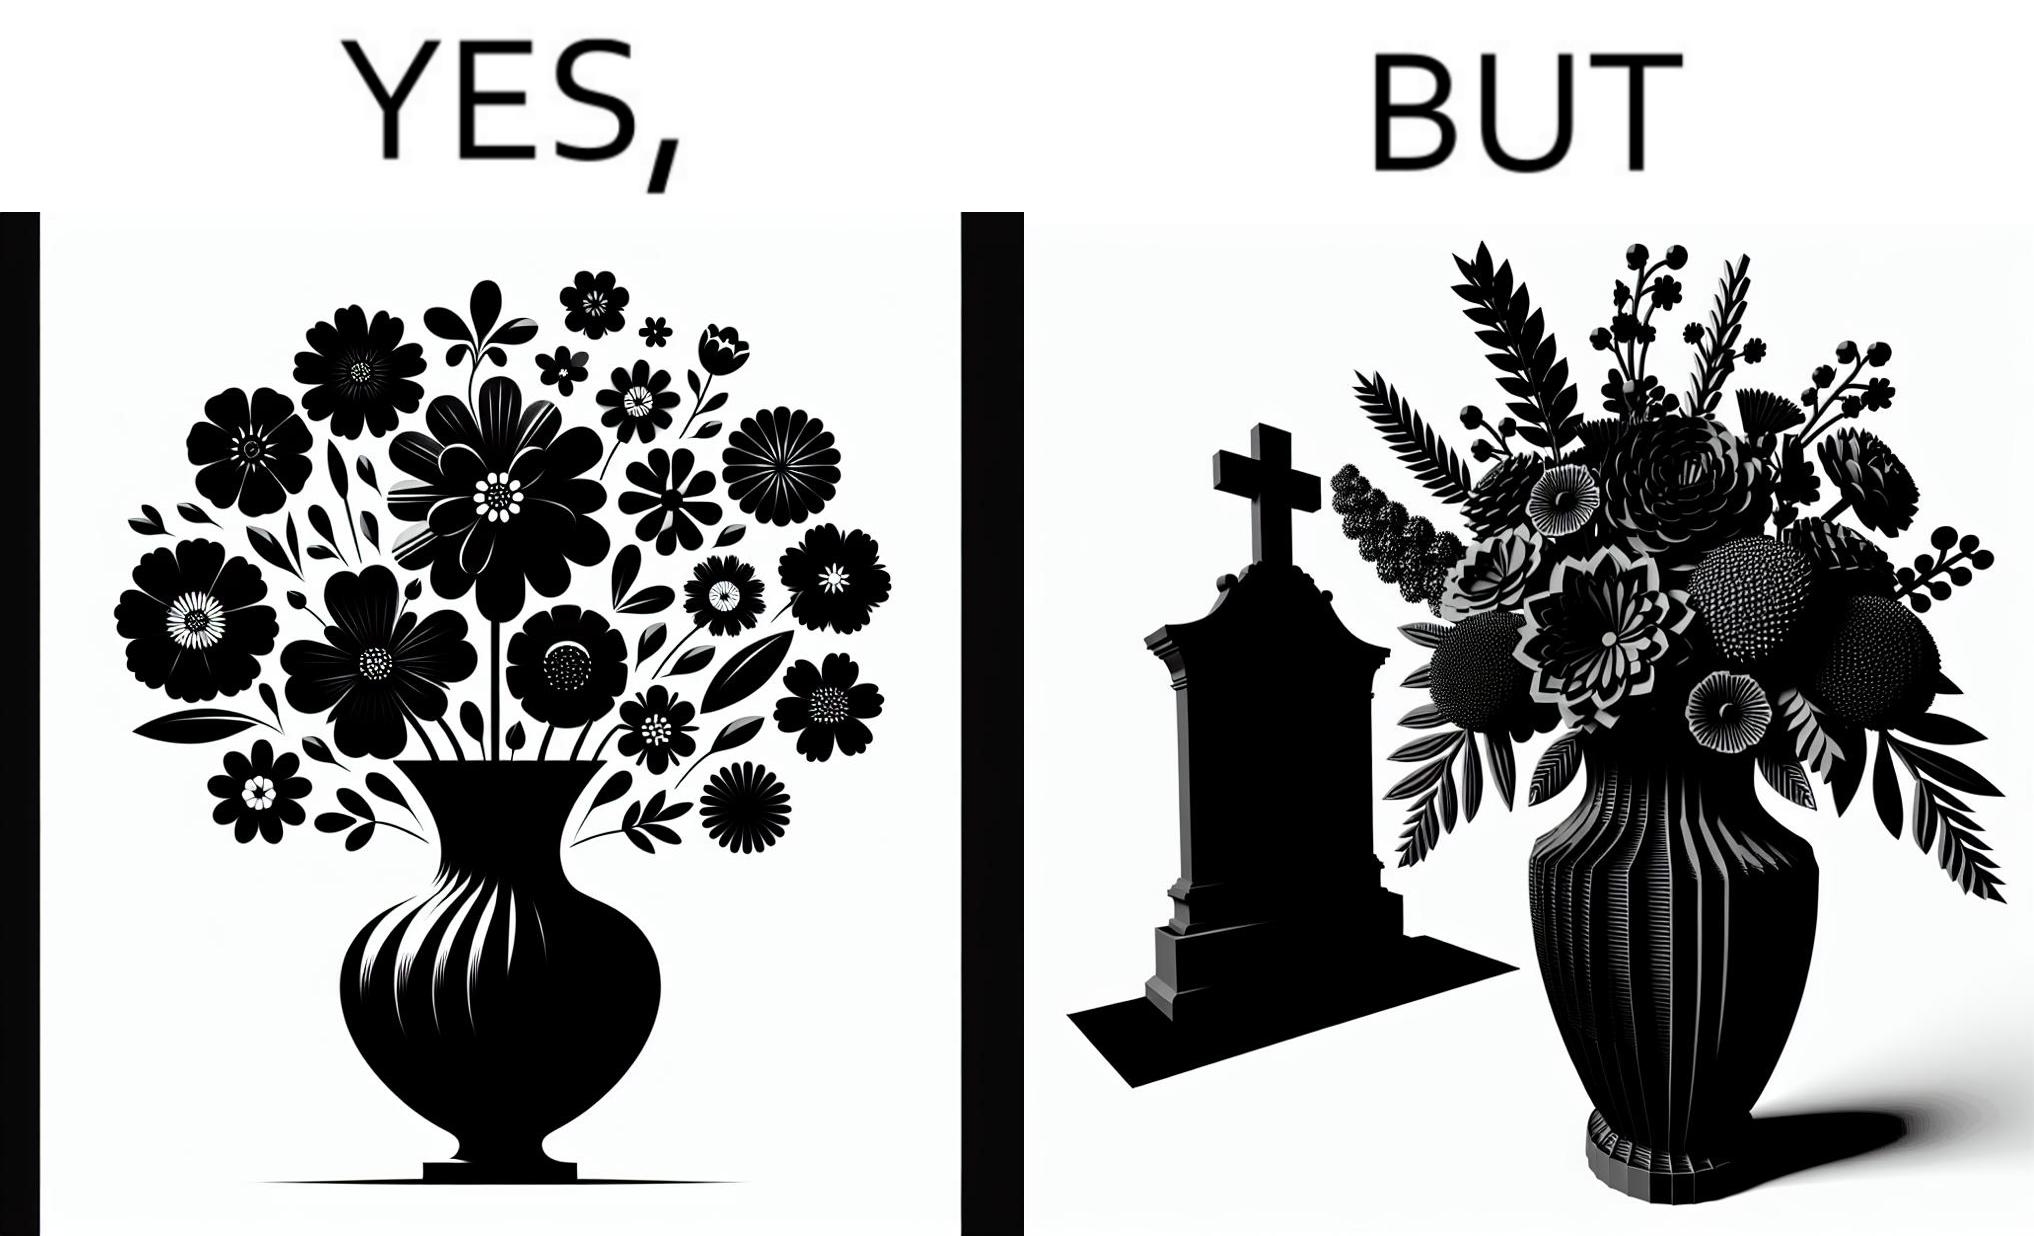Describe the contrast between the left and right parts of this image. In the left part of the image: a beautiful vase of full of different beautiful flowers In the right part of the image: a beautiful vase of full of different beautiful flowers put in front of someone's grave stone 